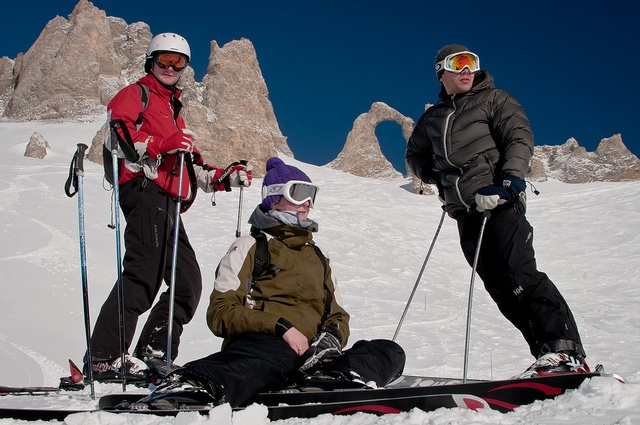Describe the objects in this image and their specific colors. I can see people in navy, black, lightgray, and maroon tones, people in navy, black, brown, gray, and maroon tones, people in navy, black, gray, and lightgray tones, skis in navy, black, darkgray, gray, and lightgray tones, and skis in navy, gray, darkgray, black, and lightgray tones in this image. 